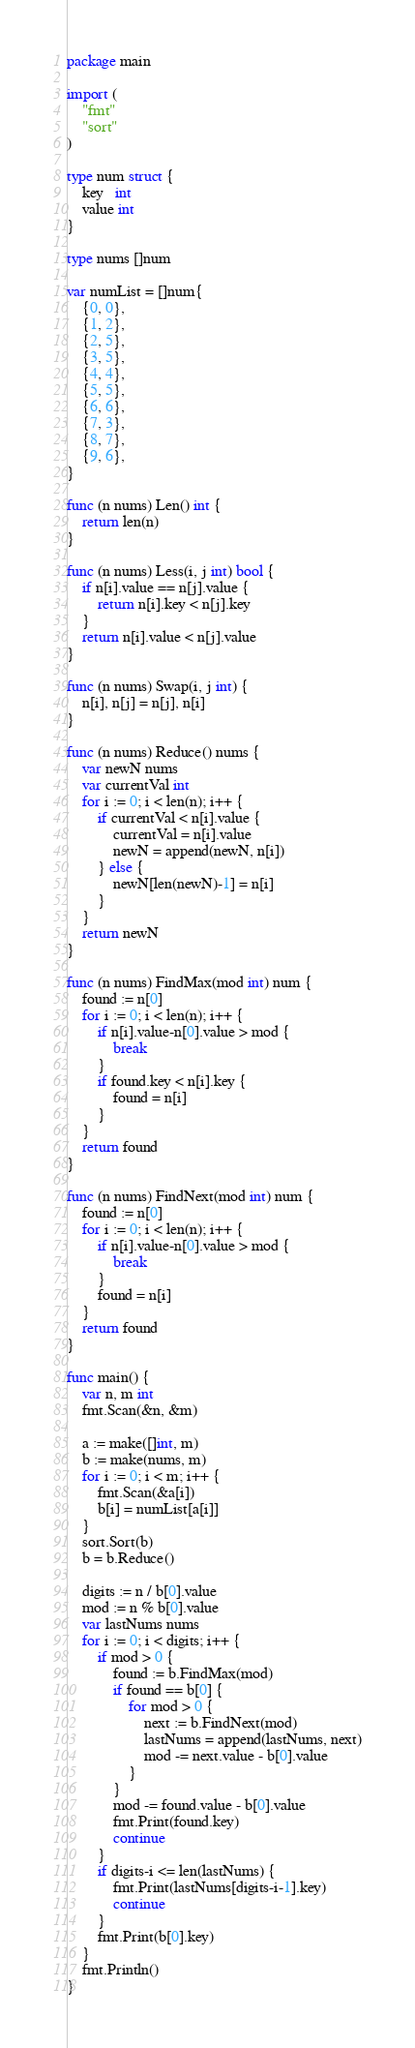Convert code to text. <code><loc_0><loc_0><loc_500><loc_500><_Go_>package main

import (
	"fmt"
	"sort"
)

type num struct {
	key   int
	value int
}

type nums []num

var numList = []num{
	{0, 0},
	{1, 2},
	{2, 5},
	{3, 5},
	{4, 4},
	{5, 5},
	{6, 6},
	{7, 3},
	{8, 7},
	{9, 6},
}

func (n nums) Len() int {
	return len(n)
}

func (n nums) Less(i, j int) bool {
	if n[i].value == n[j].value {
		return n[i].key < n[j].key
	}
	return n[i].value < n[j].value
}

func (n nums) Swap(i, j int) {
	n[i], n[j] = n[j], n[i]
}

func (n nums) Reduce() nums {
	var newN nums
	var currentVal int
	for i := 0; i < len(n); i++ {
		if currentVal < n[i].value {
			currentVal = n[i].value
			newN = append(newN, n[i])
		} else {
			newN[len(newN)-1] = n[i]
		}
	}
	return newN
}

func (n nums) FindMax(mod int) num {
	found := n[0]
	for i := 0; i < len(n); i++ {
		if n[i].value-n[0].value > mod {
			break
		}
		if found.key < n[i].key {
			found = n[i]
		}
	}
	return found
}

func (n nums) FindNext(mod int) num {
	found := n[0]
	for i := 0; i < len(n); i++ {
		if n[i].value-n[0].value > mod {
			break
		}
		found = n[i]
	}
	return found
}

func main() {
	var n, m int
	fmt.Scan(&n, &m)

	a := make([]int, m)
	b := make(nums, m)
	for i := 0; i < m; i++ {
		fmt.Scan(&a[i])
		b[i] = numList[a[i]]
	}
	sort.Sort(b)
	b = b.Reduce()

	digits := n / b[0].value
	mod := n % b[0].value
	var lastNums nums
	for i := 0; i < digits; i++ {
		if mod > 0 {
			found := b.FindMax(mod)
			if found == b[0] {
				for mod > 0 {
					next := b.FindNext(mod)
					lastNums = append(lastNums, next)
					mod -= next.value - b[0].value
				}
			}
			mod -= found.value - b[0].value
			fmt.Print(found.key)
			continue
		}
		if digits-i <= len(lastNums) {
			fmt.Print(lastNums[digits-i-1].key)
			continue
		}
		fmt.Print(b[0].key)
	}
	fmt.Println()
}</code> 